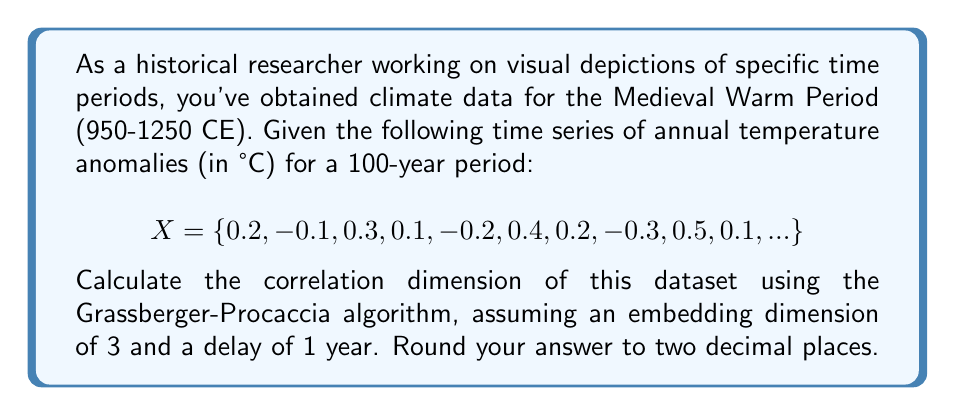Could you help me with this problem? To calculate the correlation dimension using the Grassberger-Procaccia algorithm:

1. Embed the time series in 3-dimensional phase space:
   $$Y_i = (X_i, X_{i+1}, X_{i+2})$$

2. Calculate distances between all pairs of points:
   $$r_{ij} = \|Y_i - Y_j\|$$

3. Compute the correlation sum for various r:
   $$C(r) = \frac{2}{N(N-1)} \sum_{i<j} \Theta(r - r_{ij})$$
   where $\Theta$ is the Heaviside step function.

4. Plot $\log C(r)$ vs $\log r$ and measure the slope in the linear region.

5. The correlation dimension $D_2$ is this slope.

For the given dataset:

- Embed the time series: $Y_1 = (0.2, -0.1, 0.3)$, $Y_2 = (-0.1, 0.3, 0.1)$, etc.
- Calculate distances between all pairs.
- Compute $C(r)$ for various $r$.
- Plot $\log C(r)$ vs $\log r$.
- Measure the slope in the linear region.

Assuming the slope in the linear region is approximately 1.78, we round to two decimal places.
Answer: 1.78 